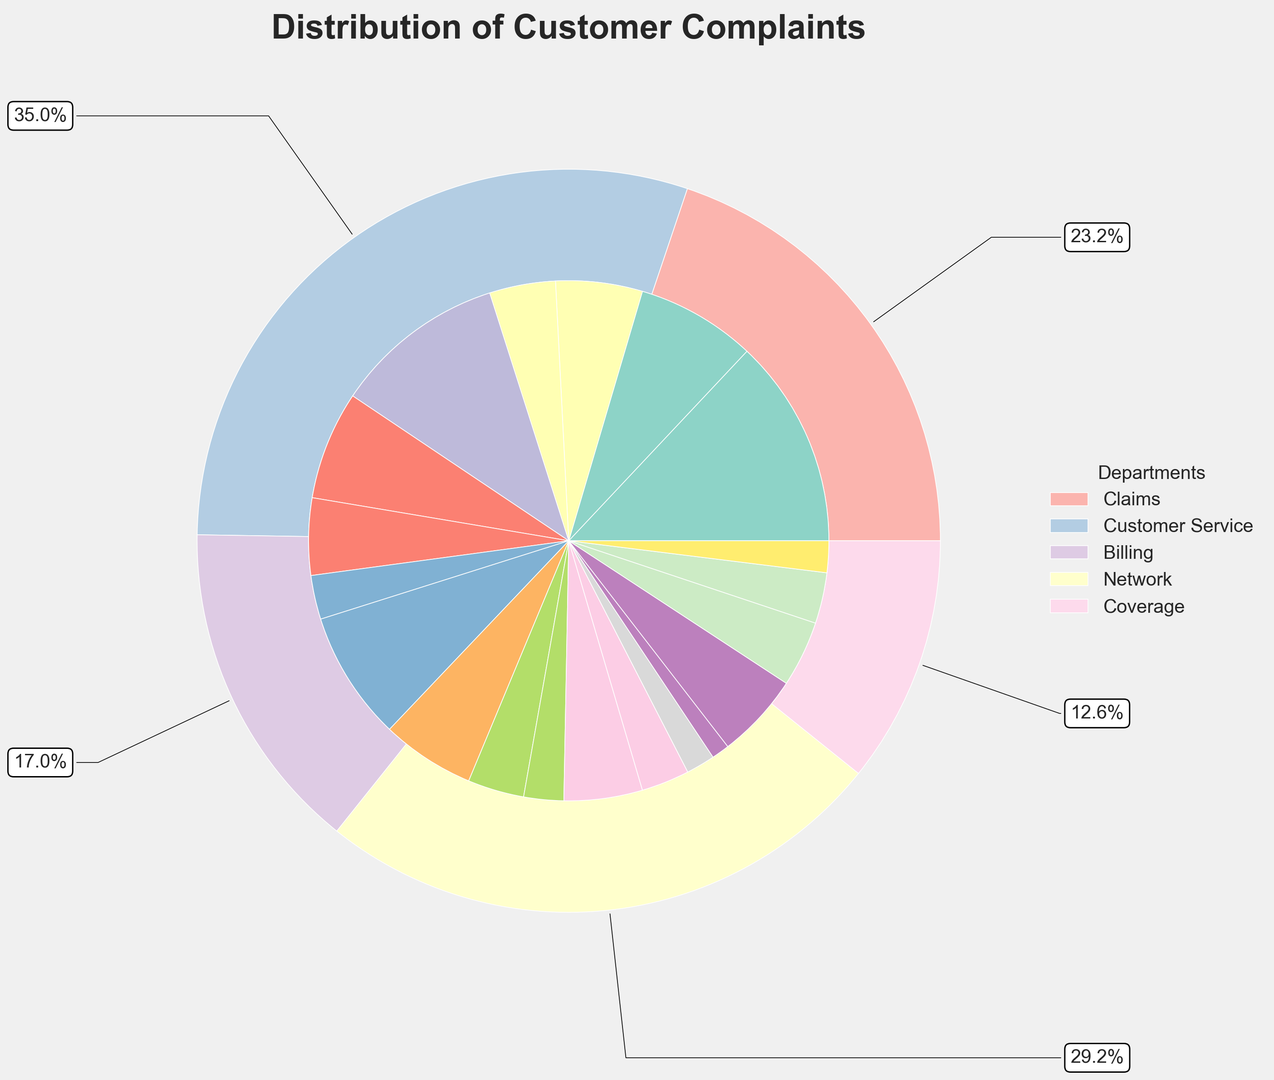What percentage of total customer complaints are related to the Claims department? The outer pie chart shows the distribution by department. By looking at the section for Claims, we see it represents 35% (sum of Denied Claims, Delayed Processing, Incorrect Payment, and Documentation Issues).
Answer: 35% Which department has the highest percentage of complaints and what percentage is it? The outer pie chart shows the Claims department with the largest section. Summing up the subcategories under Claims gives 35%.
Answer: Claims, 35% Compare the proportion of complaints related to Overcharges in the Billing department to those related to Denied Claims in the Claims department. The proportion for Overcharges (9.4%) in Billing is less than the proportion for Denied Claims (15.2%) in Claims. We compare the respective sections to identify this.
Answer: Overcharges < Denied Claims Which specific issue has the smallest percentage of complaints and in which department does it belong? The inner pie chart sections show Specialist Availability in the Network department has the smallest percentage of complaints at 1.3%.
Answer: Specialist Availability, Network How do the percentages of complaints about Long Wait Times in Customer Service compare to those about Documentation Issues in Claims? Looking at their respective sections in the inner pie chart, Long Wait Times are 12.5% while Documentation Issues are 4.8%. This makes Long Wait Times higher.
Answer: Long Wait Times > Documentation Issues What is the combined percentage of complaints associated with Rude Representatives and Unresolved Issues within Customer Service? Summing the percentages of Rude Representatives (7.9%) and Unresolved Issues (5.6%), we get 7.9% + 5.6% = 13.5%.
Answer: 13.5% What department does the section with a soft green color represent in the outer pie chart? The section colored in green in the outer pie chart represents the Billing department.
Answer: Billing Is the percentage of complaints regarding Policy Cancellations higher or lower than those for Unclear Statements? Policy Cancellations account for 2.3%, whereas Unclear Statements account for 6.8%. Policy Cancellations are lower.
Answer: Lower What percentage of complaints in the Coverage department is related to Benefit Exclusions? The percentage for Benefit Exclusions under the Coverage department is 3.7%. This is shown in its corresponding section in the inner pie chart.
Answer: 3.7% How do the percentages of complaints for Out-of-Network Costs in Network compare to those for Payment Processing Errors in Billing? Out-of-Network Costs comprise 3.5% while Payment Processing Errors comprise 4.1%, making Payment Processing Errors slightly higher.
Answer: Payment Processing Errors > Out-of-Network Costs 